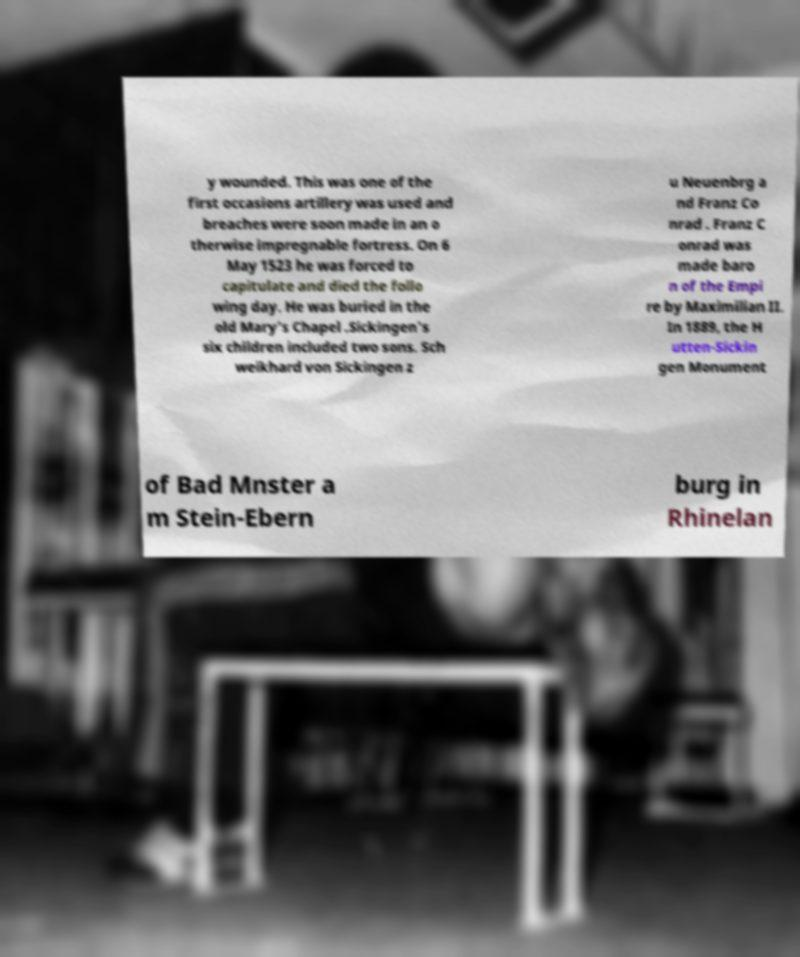Could you assist in decoding the text presented in this image and type it out clearly? y wounded. This was one of the first occasions artillery was used and breaches were soon made in an o therwise impregnable fortress. On 6 May 1523 he was forced to capitulate and died the follo wing day. He was buried in the old Mary's Chapel .Sickingen's six children included two sons. Sch weikhard von Sickingen z u Neuenbrg a nd Franz Co nrad . Franz C onrad was made baro n of the Empi re by Maximilian II. In 1889, the H utten-Sickin gen Monument of Bad Mnster a m Stein-Ebern burg in Rhinelan 